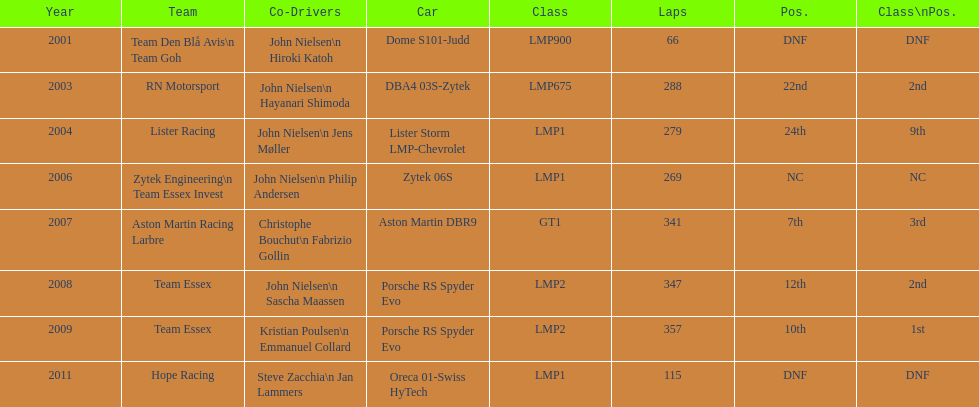Who was john nielsen co-driver for team lister in 2004? Jens Møller. Help me parse the entirety of this table. {'header': ['Year', 'Team', 'Co-Drivers', 'Car', 'Class', 'Laps', 'Pos.', 'Class\\nPos.'], 'rows': [['2001', 'Team Den Blå Avis\\n Team Goh', 'John Nielsen\\n Hiroki Katoh', 'Dome S101-Judd', 'LMP900', '66', 'DNF', 'DNF'], ['2003', 'RN Motorsport', 'John Nielsen\\n Hayanari Shimoda', 'DBA4 03S-Zytek', 'LMP675', '288', '22nd', '2nd'], ['2004', 'Lister Racing', 'John Nielsen\\n Jens Møller', 'Lister Storm LMP-Chevrolet', 'LMP1', '279', '24th', '9th'], ['2006', 'Zytek Engineering\\n Team Essex Invest', 'John Nielsen\\n Philip Andersen', 'Zytek 06S', 'LMP1', '269', 'NC', 'NC'], ['2007', 'Aston Martin Racing Larbre', 'Christophe Bouchut\\n Fabrizio Gollin', 'Aston Martin DBR9', 'GT1', '341', '7th', '3rd'], ['2008', 'Team Essex', 'John Nielsen\\n Sascha Maassen', 'Porsche RS Spyder Evo', 'LMP2', '347', '12th', '2nd'], ['2009', 'Team Essex', 'Kristian Poulsen\\n Emmanuel Collard', 'Porsche RS Spyder Evo', 'LMP2', '357', '10th', '1st'], ['2011', 'Hope Racing', 'Steve Zacchia\\n Jan Lammers', 'Oreca 01-Swiss HyTech', 'LMP1', '115', 'DNF', 'DNF']]} 